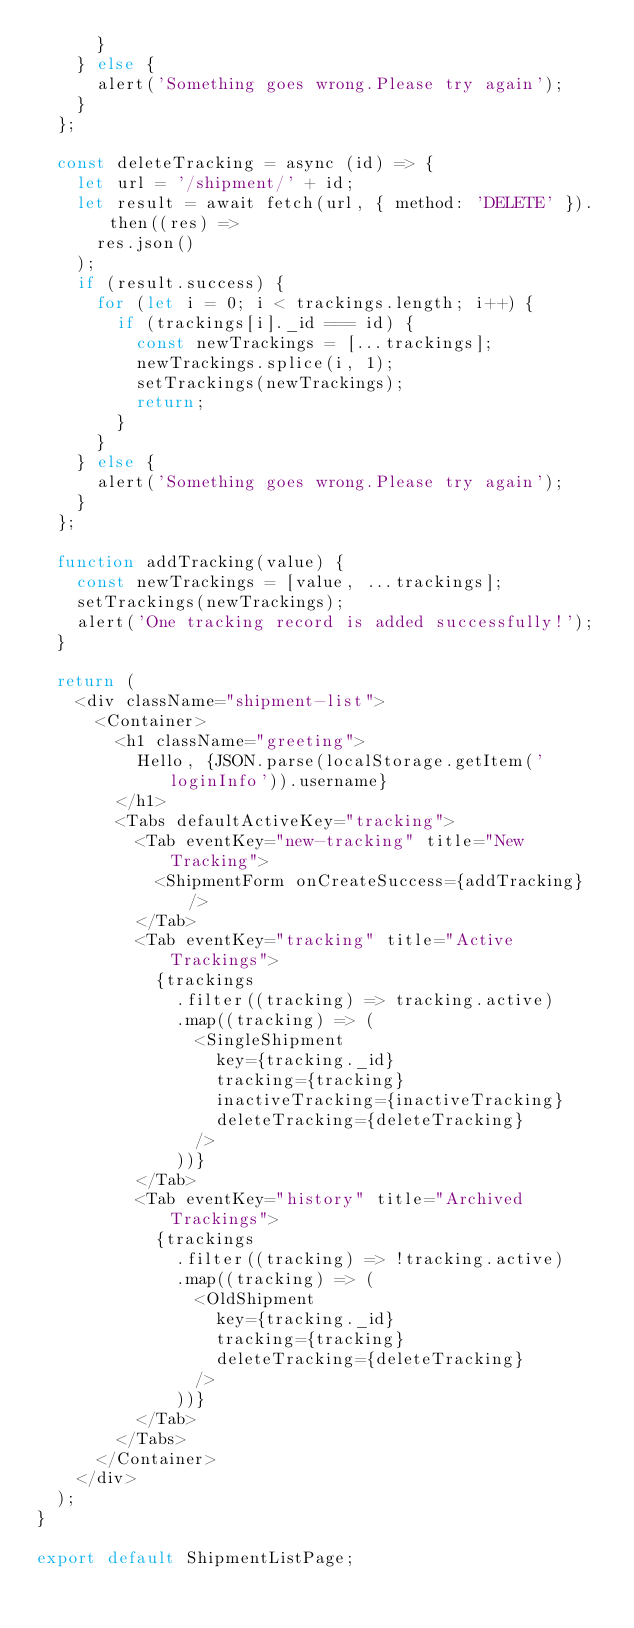<code> <loc_0><loc_0><loc_500><loc_500><_JavaScript_>      }
    } else {
      alert('Something goes wrong.Please try again');
    }
  };

  const deleteTracking = async (id) => {
    let url = '/shipment/' + id;
    let result = await fetch(url, { method: 'DELETE' }).then((res) =>
      res.json()
    );
    if (result.success) {
      for (let i = 0; i < trackings.length; i++) {
        if (trackings[i]._id === id) {
          const newTrackings = [...trackings];
          newTrackings.splice(i, 1);
          setTrackings(newTrackings);
          return;
        }
      }
    } else {
      alert('Something goes wrong.Please try again');
    }
  };

  function addTracking(value) {
    const newTrackings = [value, ...trackings];
    setTrackings(newTrackings);
    alert('One tracking record is added successfully!');
  }

  return (
    <div className="shipment-list">
      <Container>
        <h1 className="greeting">
          Hello, {JSON.parse(localStorage.getItem('loginInfo')).username}
        </h1>
        <Tabs defaultActiveKey="tracking">
          <Tab eventKey="new-tracking" title="New Tracking">
            <ShipmentForm onCreateSuccess={addTracking} />
          </Tab>
          <Tab eventKey="tracking" title="Active Trackings">
            {trackings
              .filter((tracking) => tracking.active)
              .map((tracking) => (
                <SingleShipment
                  key={tracking._id}
                  tracking={tracking}
                  inactiveTracking={inactiveTracking}
                  deleteTracking={deleteTracking}
                />
              ))}
          </Tab>
          <Tab eventKey="history" title="Archived Trackings">
            {trackings
              .filter((tracking) => !tracking.active)
              .map((tracking) => (
                <OldShipment
                  key={tracking._id}
                  tracking={tracking}
                  deleteTracking={deleteTracking}
                />
              ))}
          </Tab>
        </Tabs>
      </Container>
    </div>
  );
}

export default ShipmentListPage;
</code> 